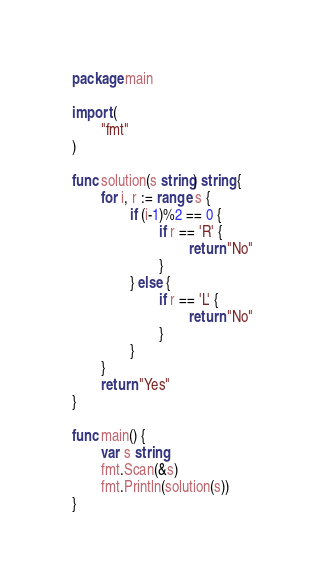Convert code to text. <code><loc_0><loc_0><loc_500><loc_500><_Go_>package main

import (
        "fmt"
)

func solution(s string) string {
        for i, r := range s {
                if (i-1)%2 == 0 {
                        if r == 'R' {
                                return "No"
                        }
                } else {
                        if r == 'L' {
                                return "No"
                        }
                }
        }
        return "Yes"
}

func main() {
        var s string
        fmt.Scan(&s)
        fmt.Println(solution(s))
}</code> 